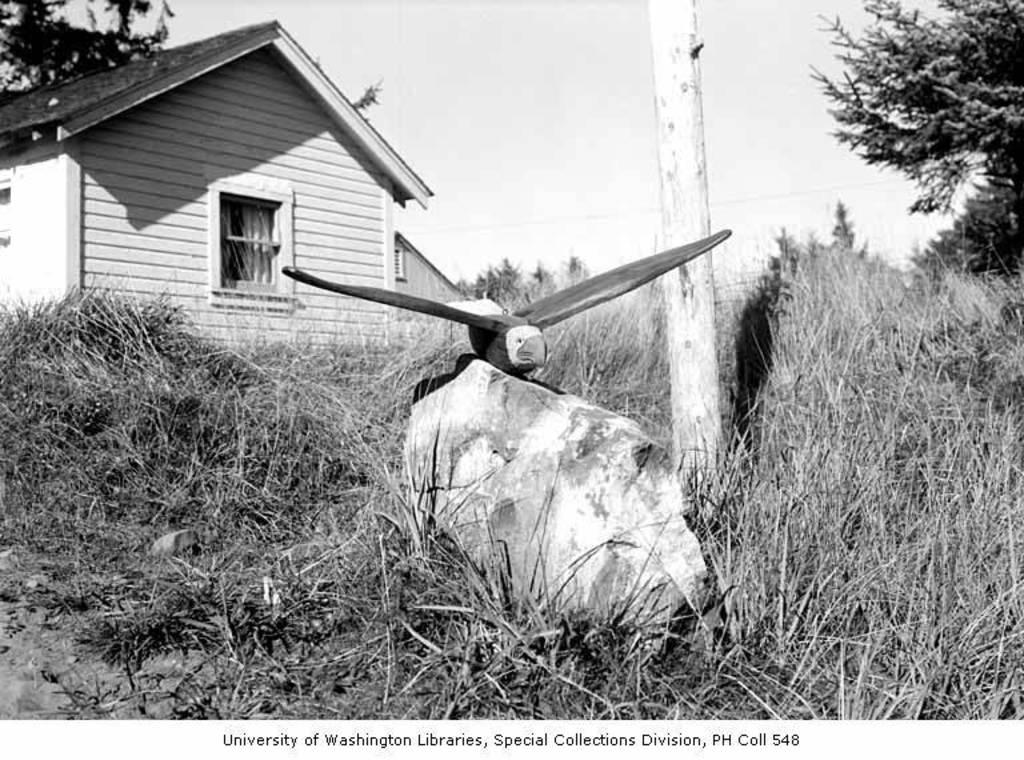<image>
Create a compact narrative representing the image presented. A black and white photograph is from the University of Washington Libraries. 